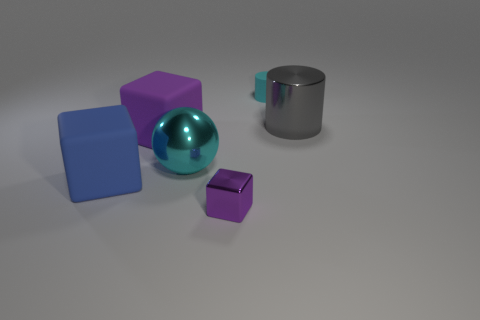Subtract all large cubes. How many cubes are left? 1 Add 2 big brown metallic things. How many objects exist? 8 Subtract all cylinders. How many objects are left? 4 Subtract all blue blocks. How many blocks are left? 2 Add 3 small gray metallic cylinders. How many small gray metallic cylinders exist? 3 Subtract 0 brown cylinders. How many objects are left? 6 Subtract 3 blocks. How many blocks are left? 0 Subtract all purple cubes. Subtract all yellow cylinders. How many cubes are left? 1 Subtract all red spheres. How many cyan cylinders are left? 1 Subtract all blue things. Subtract all cyan matte cylinders. How many objects are left? 4 